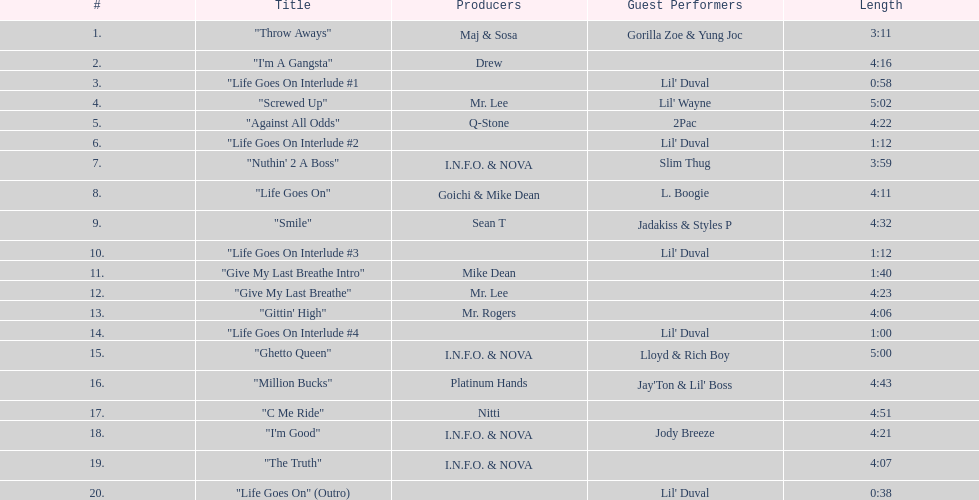Which producers produced the majority of songs on this record? I.N.F.O. & NOVA. 